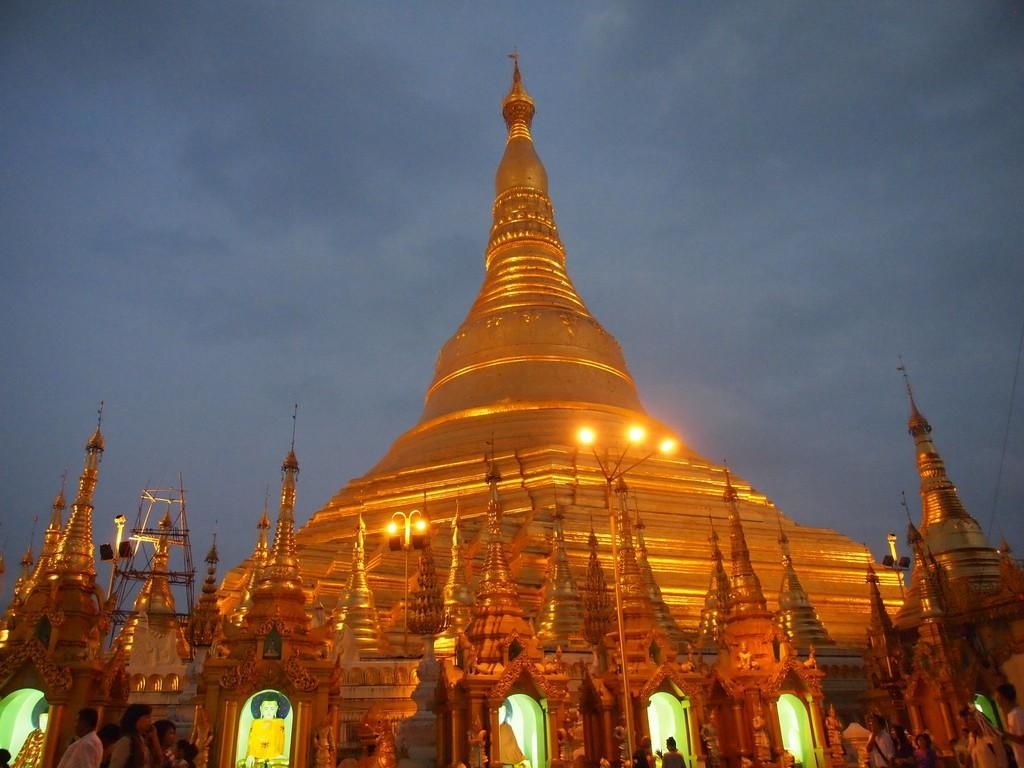What type of structure is present in the image? There is a building in the image. What colors are used to depict the building? The building is in orange and yellow colors. What can be seen illuminated in the image? There are lights visible in the image. Who or what is present in the image besides the building? There are people in the image. What colors are used to depict the sky in the image? The sky is in blue and white colors. How old is the baby in the image? There is no baby present in the image. What type of sorting activity is being performed by the people in the image? There is no sorting activity depicted in the image; the people are simply present. 